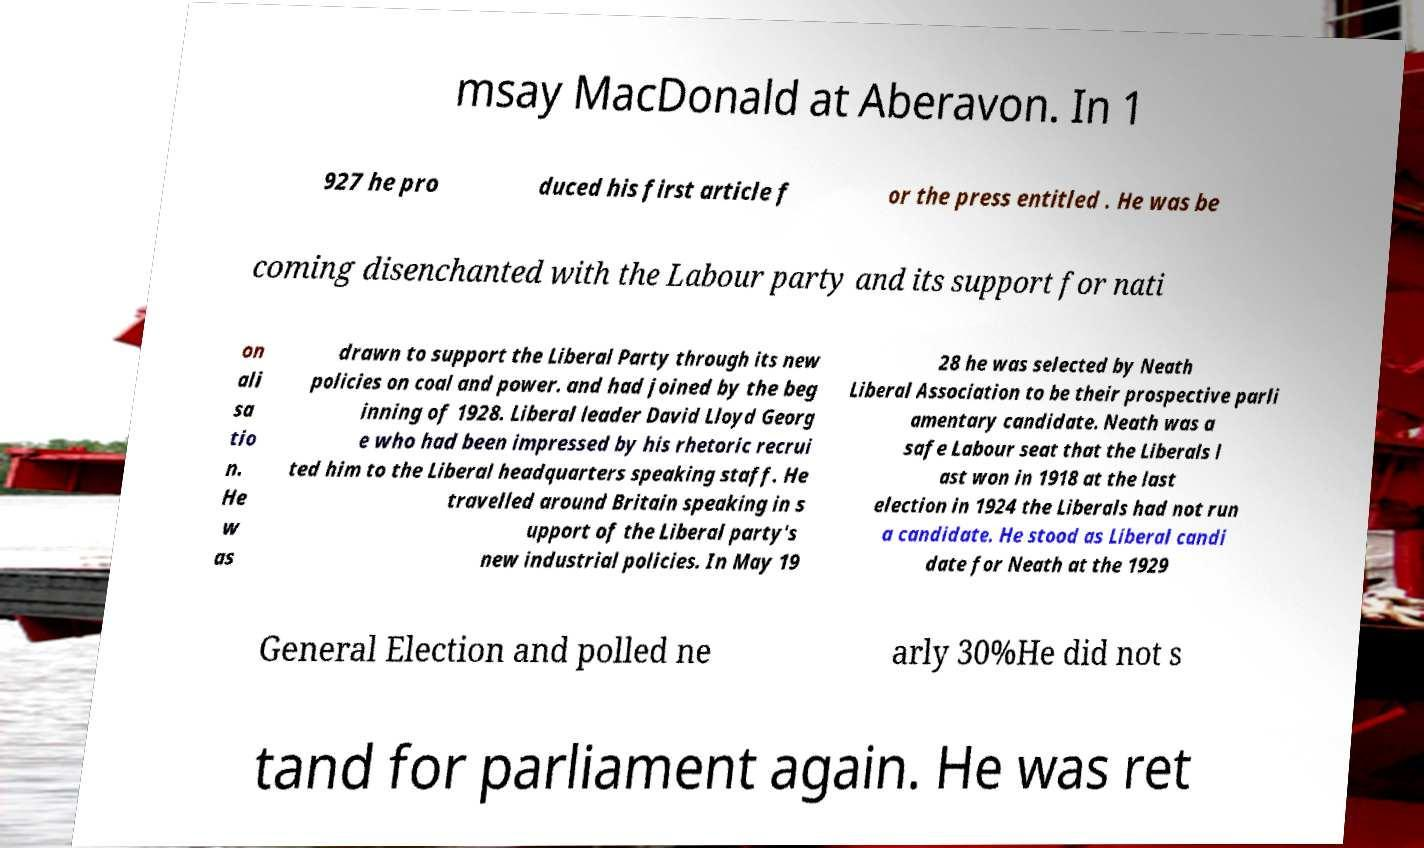Please identify and transcribe the text found in this image. msay MacDonald at Aberavon. In 1 927 he pro duced his first article f or the press entitled . He was be coming disenchanted with the Labour party and its support for nati on ali sa tio n. He w as drawn to support the Liberal Party through its new policies on coal and power. and had joined by the beg inning of 1928. Liberal leader David Lloyd Georg e who had been impressed by his rhetoric recrui ted him to the Liberal headquarters speaking staff. He travelled around Britain speaking in s upport of the Liberal party's new industrial policies. In May 19 28 he was selected by Neath Liberal Association to be their prospective parli amentary candidate. Neath was a safe Labour seat that the Liberals l ast won in 1918 at the last election in 1924 the Liberals had not run a candidate. He stood as Liberal candi date for Neath at the 1929 General Election and polled ne arly 30%He did not s tand for parliament again. He was ret 